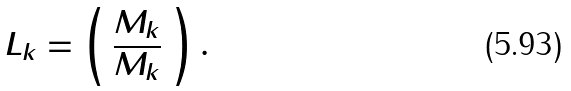Convert formula to latex. <formula><loc_0><loc_0><loc_500><loc_500>L _ { k } = \left ( \begin{array} { c } M _ { k } \\ \overline { M _ { k } } \\ \end{array} \right ) .</formula> 